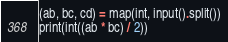<code> <loc_0><loc_0><loc_500><loc_500><_Python_>(ab, bc, cd) = map(int, input().split())
print(int((ab * bc) / 2))</code> 